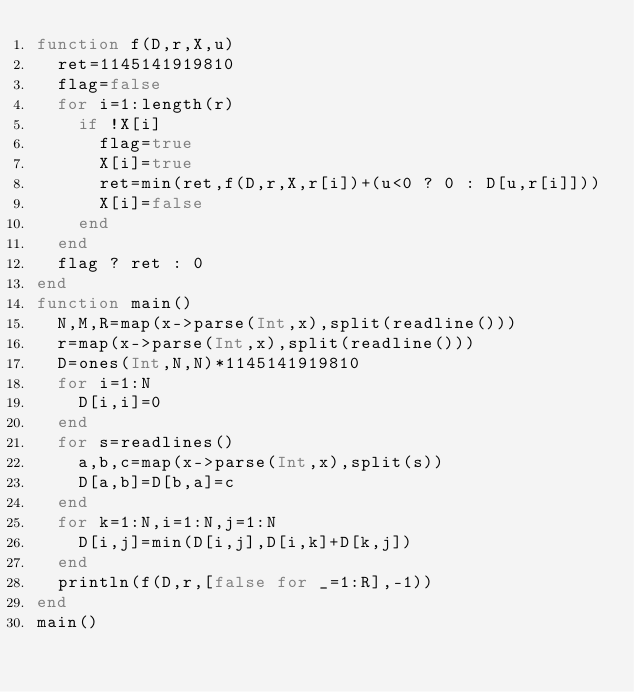Convert code to text. <code><loc_0><loc_0><loc_500><loc_500><_Julia_>function f(D,r,X,u)
	ret=1145141919810
	flag=false
	for i=1:length(r)
		if !X[i]
			flag=true
			X[i]=true
			ret=min(ret,f(D,r,X,r[i])+(u<0 ? 0 : D[u,r[i]]))
			X[i]=false
		end
	end
	flag ? ret : 0
end
function main()
	N,M,R=map(x->parse(Int,x),split(readline()))
	r=map(x->parse(Int,x),split(readline()))
	D=ones(Int,N,N)*1145141919810
	for i=1:N
		D[i,i]=0
	end
	for s=readlines()
		a,b,c=map(x->parse(Int,x),split(s))
		D[a,b]=D[b,a]=c
	end
	for k=1:N,i=1:N,j=1:N
		D[i,j]=min(D[i,j],D[i,k]+D[k,j])
	end
	println(f(D,r,[false for _=1:R],-1))
end
main()
</code> 